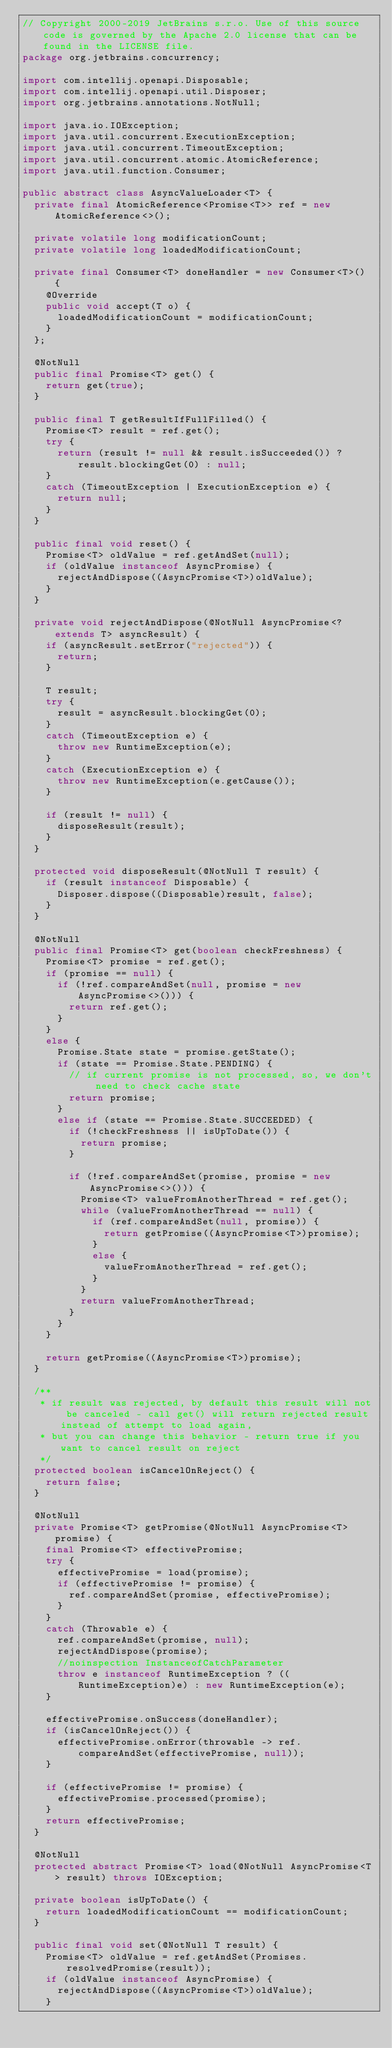Convert code to text. <code><loc_0><loc_0><loc_500><loc_500><_Java_>// Copyright 2000-2019 JetBrains s.r.o. Use of this source code is governed by the Apache 2.0 license that can be found in the LICENSE file.
package org.jetbrains.concurrency;

import com.intellij.openapi.Disposable;
import com.intellij.openapi.util.Disposer;
import org.jetbrains.annotations.NotNull;

import java.io.IOException;
import java.util.concurrent.ExecutionException;
import java.util.concurrent.TimeoutException;
import java.util.concurrent.atomic.AtomicReference;
import java.util.function.Consumer;

public abstract class AsyncValueLoader<T> {
  private final AtomicReference<Promise<T>> ref = new AtomicReference<>();

  private volatile long modificationCount;
  private volatile long loadedModificationCount;

  private final Consumer<T> doneHandler = new Consumer<T>() {
    @Override
    public void accept(T o) {
      loadedModificationCount = modificationCount;
    }
  };

  @NotNull
  public final Promise<T> get() {
    return get(true);
  }

  public final T getResultIfFullFilled() {
    Promise<T> result = ref.get();
    try {
      return (result != null && result.isSucceeded()) ? result.blockingGet(0) : null;
    }
    catch (TimeoutException | ExecutionException e) {
      return null;
    }
  }

  public final void reset() {
    Promise<T> oldValue = ref.getAndSet(null);
    if (oldValue instanceof AsyncPromise) {
      rejectAndDispose((AsyncPromise<T>)oldValue);
    }
  }

  private void rejectAndDispose(@NotNull AsyncPromise<? extends T> asyncResult) {
    if (asyncResult.setError("rejected")) {
      return;
    }

    T result;
    try {
      result = asyncResult.blockingGet(0);
    }
    catch (TimeoutException e) {
      throw new RuntimeException(e);
    }
    catch (ExecutionException e) {
      throw new RuntimeException(e.getCause());
    }

    if (result != null) {
      disposeResult(result);
    }
  }

  protected void disposeResult(@NotNull T result) {
    if (result instanceof Disposable) {
      Disposer.dispose((Disposable)result, false);
    }
  }

  @NotNull
  public final Promise<T> get(boolean checkFreshness) {
    Promise<T> promise = ref.get();
    if (promise == null) {
      if (!ref.compareAndSet(null, promise = new AsyncPromise<>())) {
        return ref.get();
      }
    }
    else {
      Promise.State state = promise.getState();
      if (state == Promise.State.PENDING) {
        // if current promise is not processed, so, we don't need to check cache state
        return promise;
      }
      else if (state == Promise.State.SUCCEEDED) {
        if (!checkFreshness || isUpToDate()) {
          return promise;
        }

        if (!ref.compareAndSet(promise, promise = new AsyncPromise<>())) {
          Promise<T> valueFromAnotherThread = ref.get();
          while (valueFromAnotherThread == null) {
            if (ref.compareAndSet(null, promise)) {
              return getPromise((AsyncPromise<T>)promise);
            }
            else {
              valueFromAnotherThread = ref.get();
            }
          }
          return valueFromAnotherThread;
        }
      }
    }

    return getPromise((AsyncPromise<T>)promise);
  }

  /**
   * if result was rejected, by default this result will not be canceled - call get() will return rejected result instead of attempt to load again,
   * but you can change this behavior - return true if you want to cancel result on reject
   */
  protected boolean isCancelOnReject() {
    return false;
  }

  @NotNull
  private Promise<T> getPromise(@NotNull AsyncPromise<T> promise) {
    final Promise<T> effectivePromise;
    try {
      effectivePromise = load(promise);
      if (effectivePromise != promise) {
        ref.compareAndSet(promise, effectivePromise);
      }
    }
    catch (Throwable e) {
      ref.compareAndSet(promise, null);
      rejectAndDispose(promise);
      //noinspection InstanceofCatchParameter
      throw e instanceof RuntimeException ? ((RuntimeException)e) : new RuntimeException(e);
    }

    effectivePromise.onSuccess(doneHandler);
    if (isCancelOnReject()) {
      effectivePromise.onError(throwable -> ref.compareAndSet(effectivePromise, null));
    }

    if (effectivePromise != promise) {
      effectivePromise.processed(promise);
    }
    return effectivePromise;
  }

  @NotNull
  protected abstract Promise<T> load(@NotNull AsyncPromise<T> result) throws IOException;

  private boolean isUpToDate() {
    return loadedModificationCount == modificationCount;
  }

  public final void set(@NotNull T result) {
    Promise<T> oldValue = ref.getAndSet(Promises.resolvedPromise(result));
    if (oldValue instanceof AsyncPromise) {
      rejectAndDispose((AsyncPromise<T>)oldValue);
    }</code> 